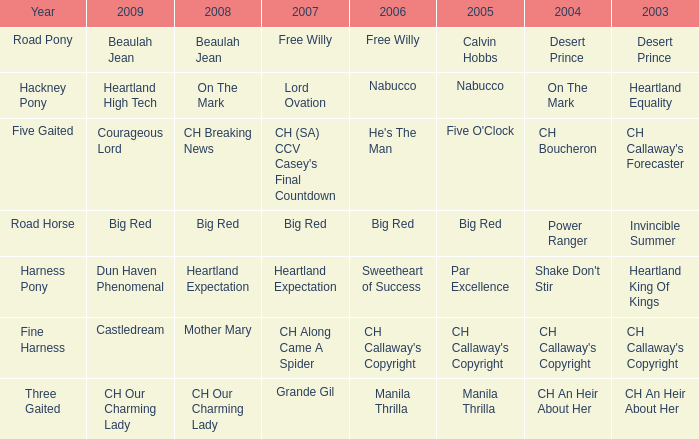What year is the 2004 shake don't stir? Harness Pony. 